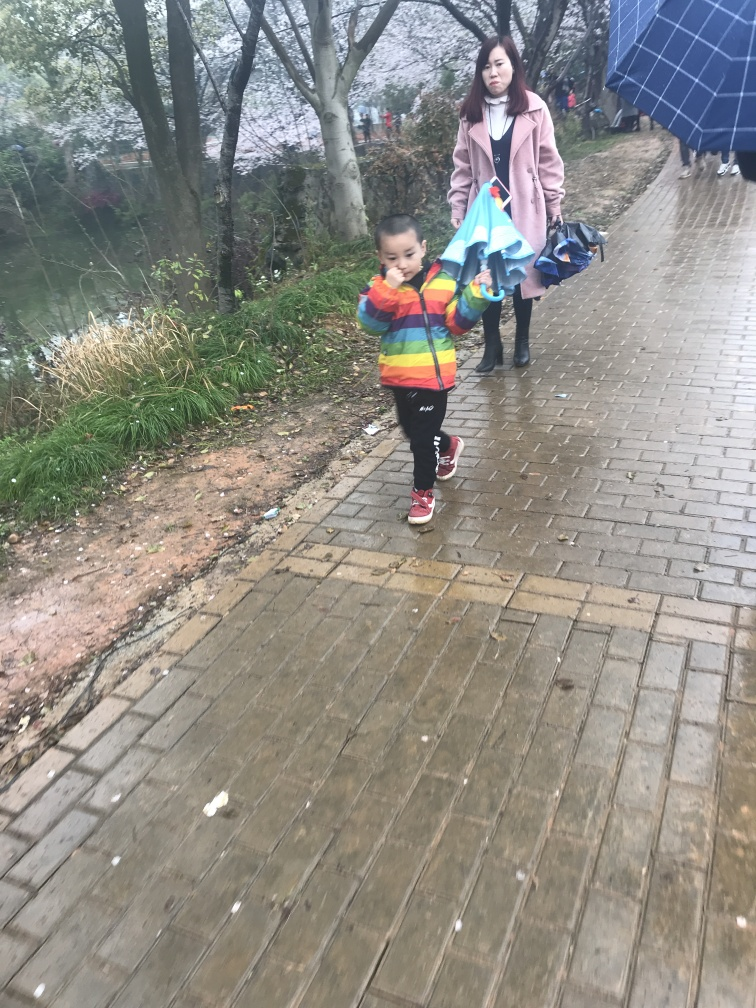What activities seem to be happening in the image? It appears to be a casual outdoor scene, likely in a park or a similar recreational area. A child, focused on something in their hands, is walking forward while an adult female, possibly the mother, is following behind carrying items, possibly after a picnic or outdoor event. 